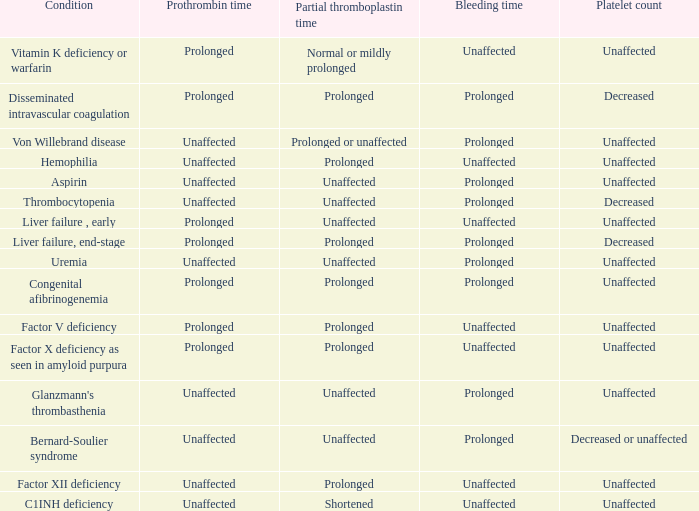Under what conditions is the prothrombin time associated with a normal platelet count, unchanged bleeding time, and a regular or mildly lengthened partial thromboplastin time? Prolonged. 